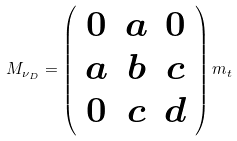Convert formula to latex. <formula><loc_0><loc_0><loc_500><loc_500>M _ { \nu _ { D } } = \left ( \begin{array} { c c c } 0 & a & 0 \\ a & b & c \\ 0 & c & d \\ \end{array} \right ) m _ { t }</formula> 